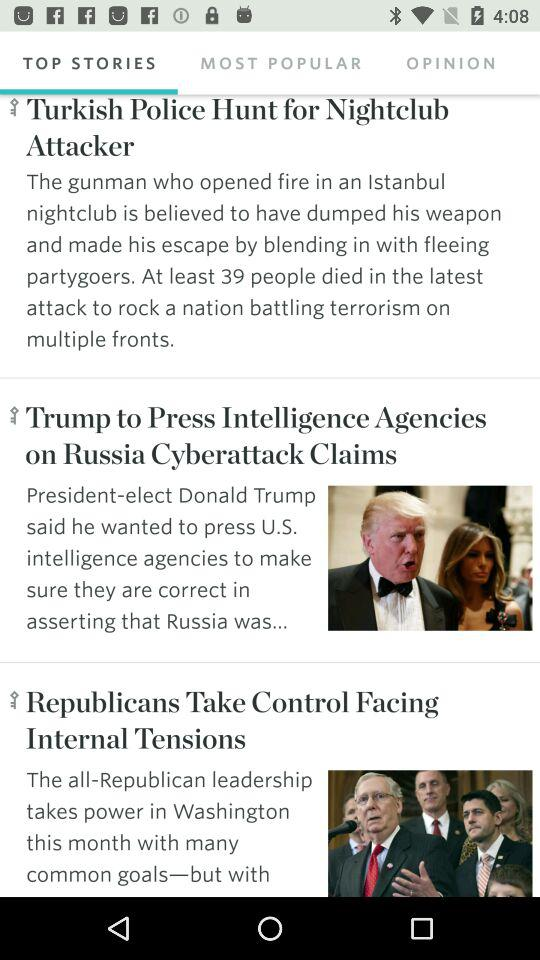Which tab is selected? The selected tab is "TOP STORIES". 